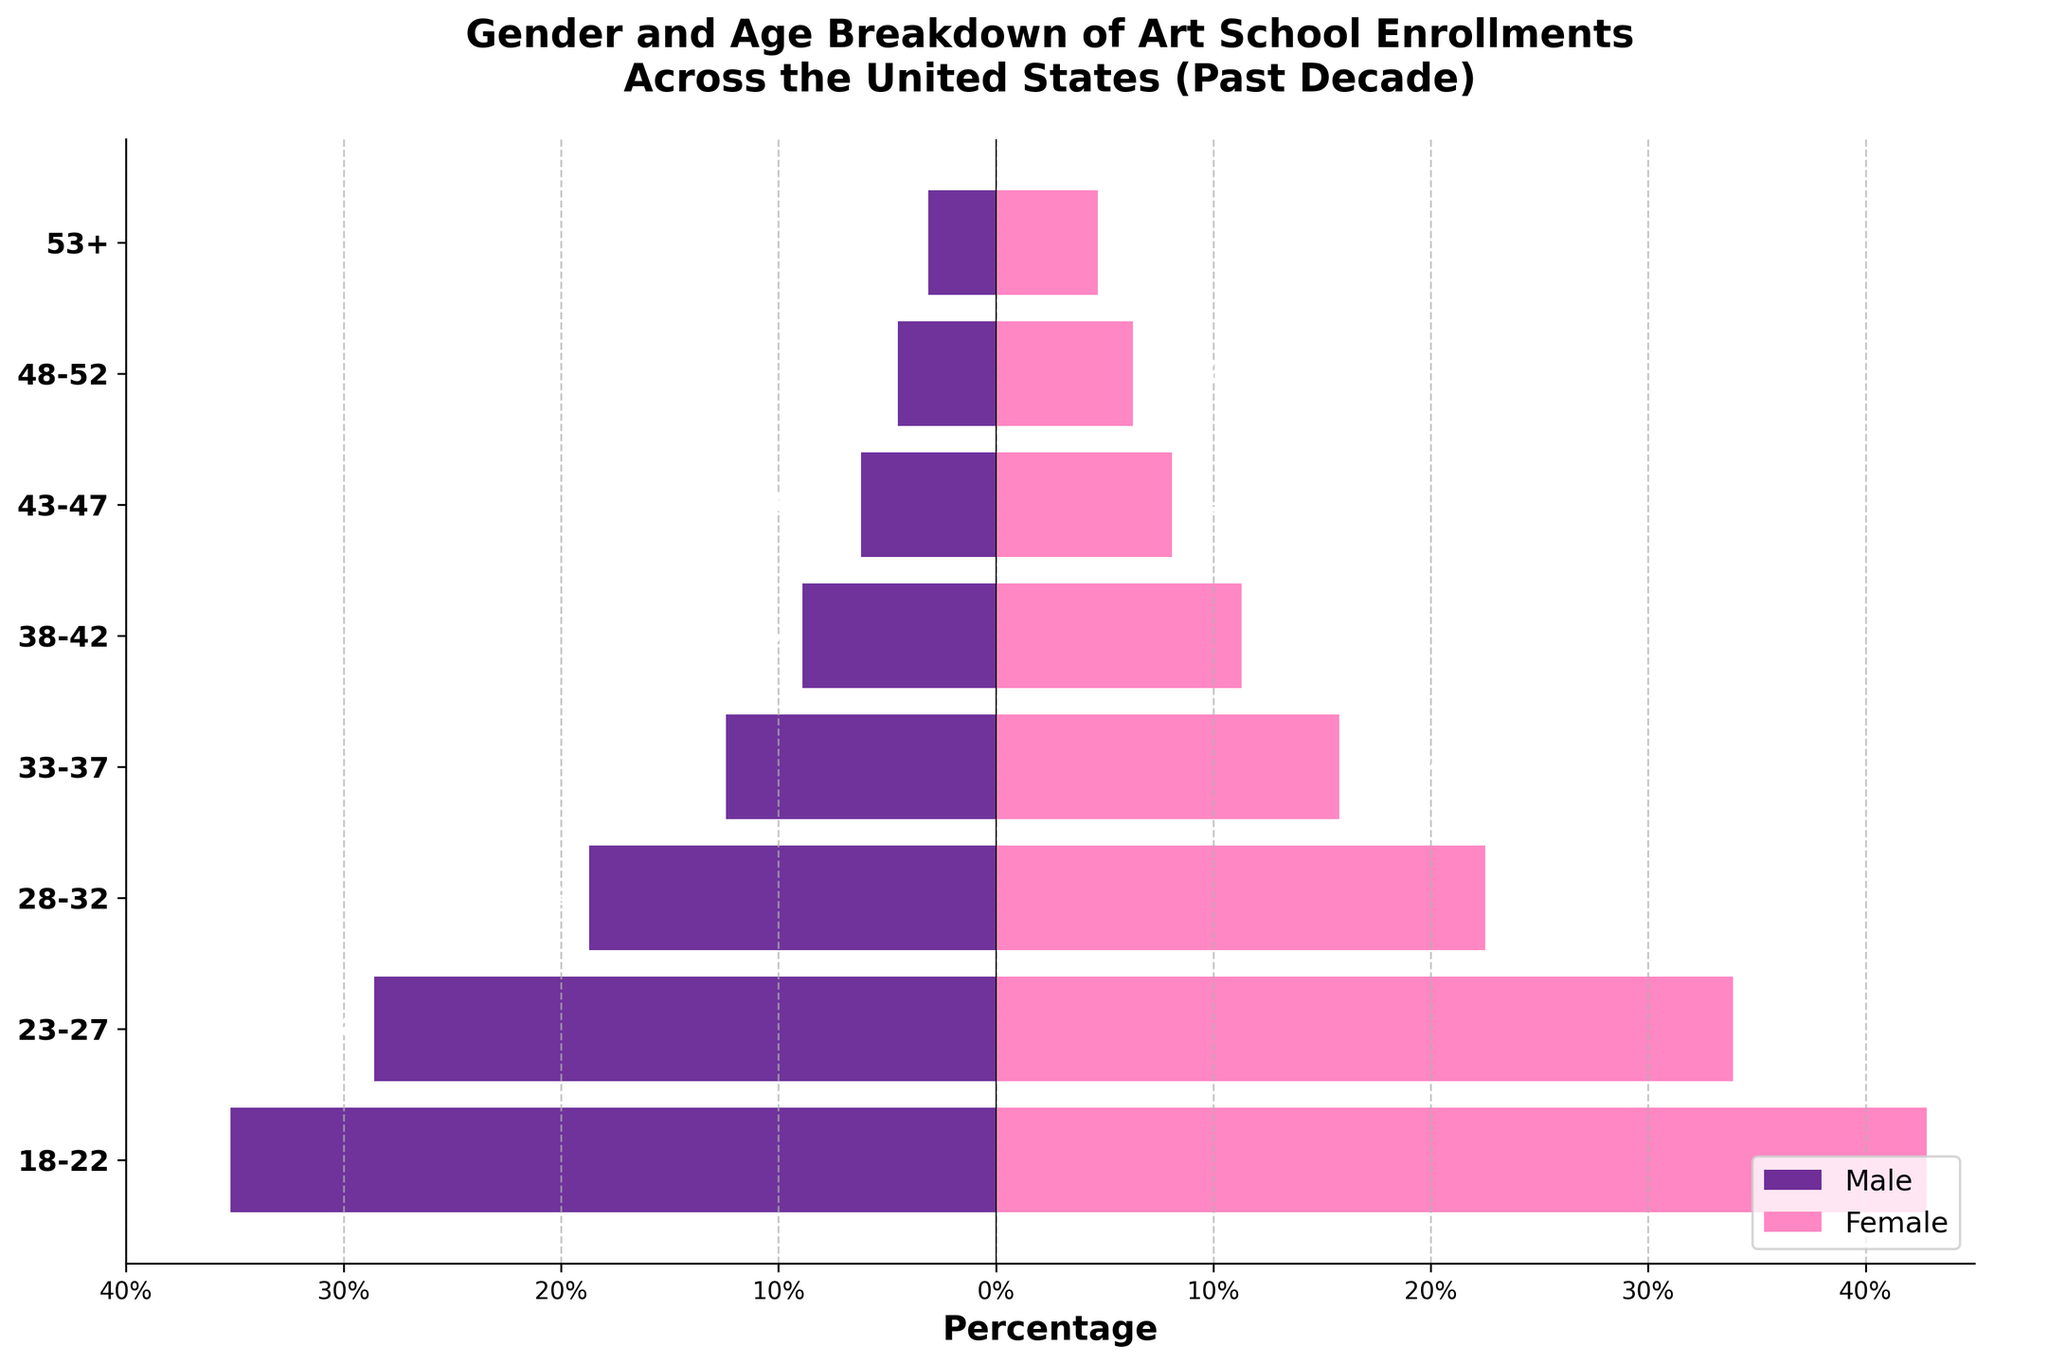What is the age group with the highest percentage of male enrollments? The figure shows the percentage of male enrollments for each age group. By looking at the lengths of the bars, we see that the age group 18-22 has the longest bar on the male side.
Answer: 18-22 What is the age group with the highest percentage of female enrollments? The figure shows the percentage of female enrollments for each age group. By looking at the lengths of the bars, we see that the age group 18-22 has the longest bar on the female side.
Answer: 18-22 Which age group has the smallest percentage of male enrollments? The figure shows the percentage of male enrollments for each age group. By comparing the lengths of the bars, we see that the age group 53+ has the shortest bar on the male side.
Answer: 53+ Which age group has the smallest percentage of female enrollments? The figure shows the percentage of female enrollments for each age group. By comparing the lengths of the bars, we see that the age group 53+ has the shortest bar on the female side.
Answer: 53+ Which gender has a higher enrollment percentage for the age group 48-52? According to the figure, the percentage of enrollments in the age group 48-52 is 4.5% for males and 6.3% for females. Since 6.3% is greater than 4.5%, females have a higher enrollment percentage.
Answer: Female What trend can be observed in the enrollments of males as the age group increases? Observing the figure, we see that the bars representing male enrollments become shorter as the age groups increase. This indicates a decreasing trend in male enrollments as age increases.
Answer: Decreasing 